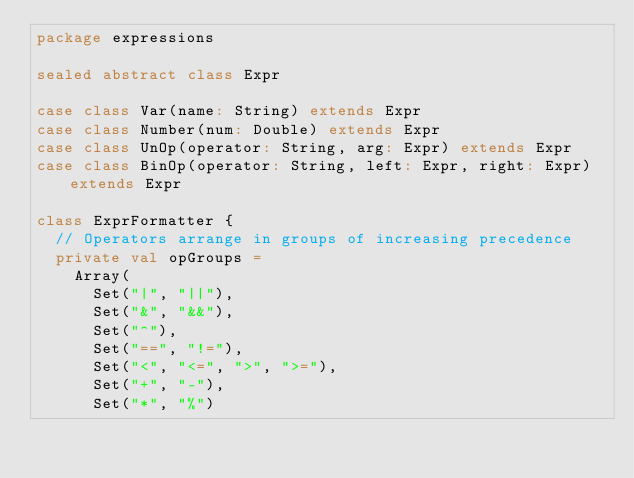Convert code to text. <code><loc_0><loc_0><loc_500><loc_500><_Scala_>package expressions

sealed abstract class Expr

case class Var(name: String) extends Expr
case class Number(num: Double) extends Expr
case class UnOp(operator: String, arg: Expr) extends Expr
case class BinOp(operator: String, left: Expr, right: Expr) extends Expr

class ExprFormatter {
  // Operators arrange in groups of increasing precedence
  private val opGroups =
    Array(
      Set("|", "||"),
      Set("&", "&&"),
      Set("^"),
      Set("==", "!="),
      Set("<", "<=", ">", ">="),
      Set("+", "-"),
      Set("*", "%")</code> 